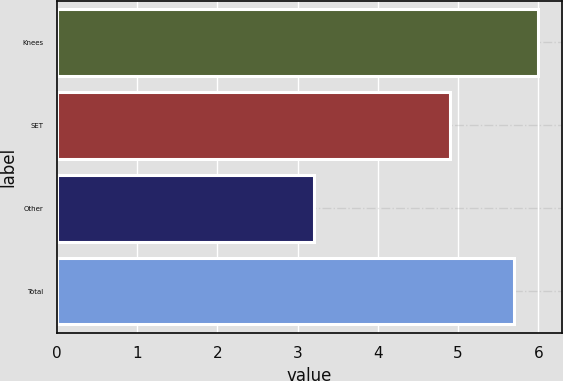Convert chart to OTSL. <chart><loc_0><loc_0><loc_500><loc_500><bar_chart><fcel>Knees<fcel>SET<fcel>Other<fcel>Total<nl><fcel>6<fcel>4.9<fcel>3.2<fcel>5.7<nl></chart> 